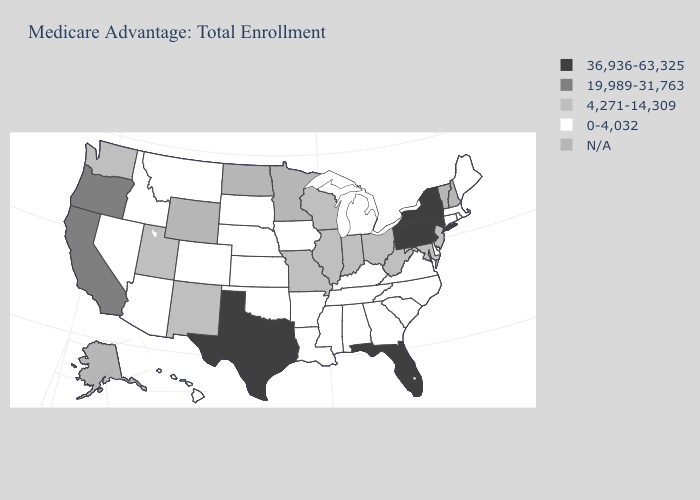Name the states that have a value in the range 4,271-14,309?
Write a very short answer. Illinois, Indiana, Maryland, Missouri, New Jersey, New Mexico, Ohio, Utah, Washington, Wisconsin, West Virginia. Name the states that have a value in the range 4,271-14,309?
Write a very short answer. Illinois, Indiana, Maryland, Missouri, New Jersey, New Mexico, Ohio, Utah, Washington, Wisconsin, West Virginia. Name the states that have a value in the range 4,271-14,309?
Concise answer only. Illinois, Indiana, Maryland, Missouri, New Jersey, New Mexico, Ohio, Utah, Washington, Wisconsin, West Virginia. What is the value of Nebraska?
Short answer required. 0-4,032. How many symbols are there in the legend?
Write a very short answer. 5. What is the value of Hawaii?
Quick response, please. 0-4,032. What is the value of Oregon?
Answer briefly. 19,989-31,763. What is the highest value in the USA?
Be succinct. 36,936-63,325. Does New Jersey have the lowest value in the USA?
Concise answer only. No. What is the value of Idaho?
Give a very brief answer. 0-4,032. Name the states that have a value in the range 0-4,032?
Concise answer only. Alabama, Arkansas, Arizona, Colorado, Connecticut, Delaware, Georgia, Hawaii, Iowa, Idaho, Kansas, Kentucky, Louisiana, Massachusetts, Maine, Michigan, Mississippi, Montana, North Carolina, Nebraska, Nevada, Oklahoma, Rhode Island, South Carolina, South Dakota, Tennessee, Virginia. Name the states that have a value in the range 19,989-31,763?
Concise answer only. California, Oregon. What is the lowest value in states that border Idaho?
Short answer required. 0-4,032. Which states have the highest value in the USA?
Quick response, please. Florida, New York, Pennsylvania, Texas. 